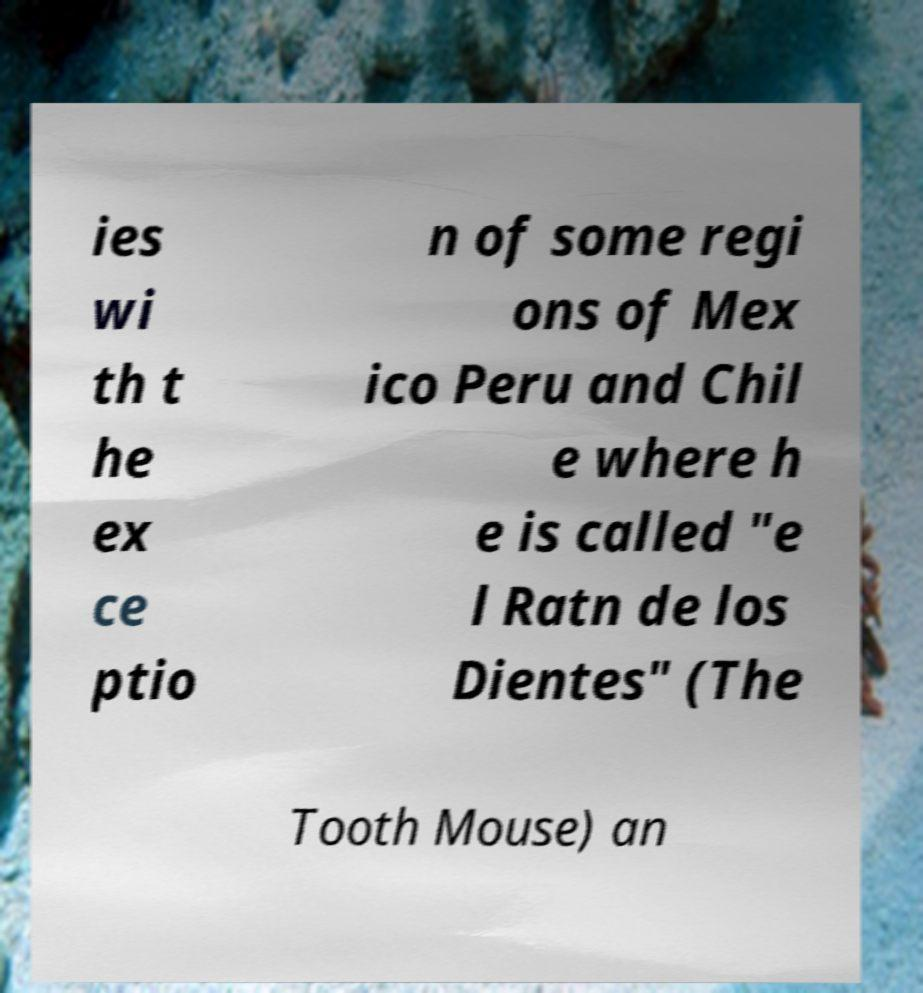Please identify and transcribe the text found in this image. ies wi th t he ex ce ptio n of some regi ons of Mex ico Peru and Chil e where h e is called "e l Ratn de los Dientes" (The Tooth Mouse) an 